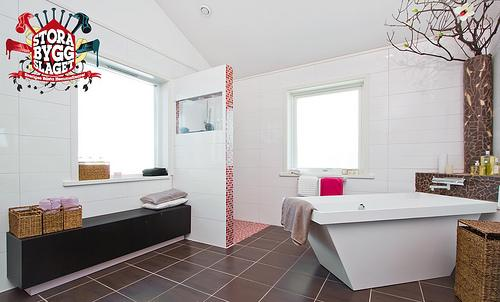How many wicket baskets are on top of the little bench near the doorway?

Choices:
A) four
B) three
C) two
D) five three 